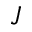<formula> <loc_0><loc_0><loc_500><loc_500>J</formula> 